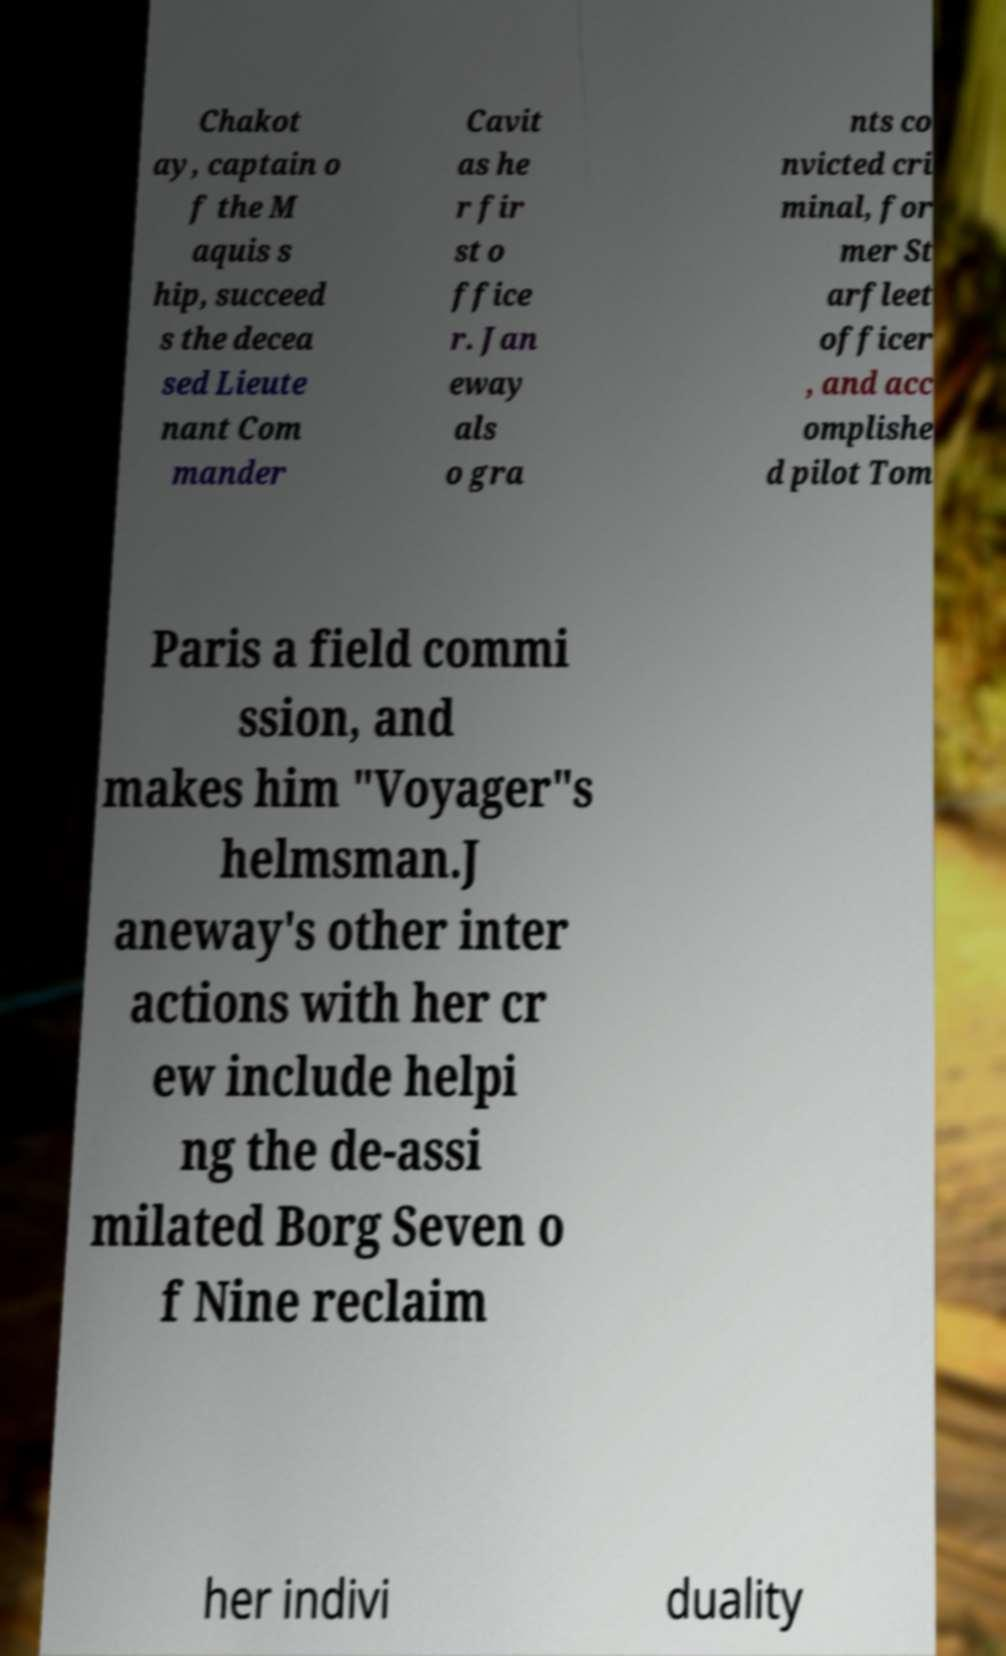Can you accurately transcribe the text from the provided image for me? Chakot ay, captain o f the M aquis s hip, succeed s the decea sed Lieute nant Com mander Cavit as he r fir st o ffice r. Jan eway als o gra nts co nvicted cri minal, for mer St arfleet officer , and acc omplishe d pilot Tom Paris a field commi ssion, and makes him "Voyager"s helmsman.J aneway's other inter actions with her cr ew include helpi ng the de-assi milated Borg Seven o f Nine reclaim her indivi duality 